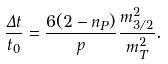<formula> <loc_0><loc_0><loc_500><loc_500>\frac { \Delta t } { t _ { 0 } } = \frac { 6 ( 2 - n _ { P } ) } { p } \frac { m _ { 3 / 2 } ^ { 2 } } { m _ { T } ^ { 2 } } .</formula> 